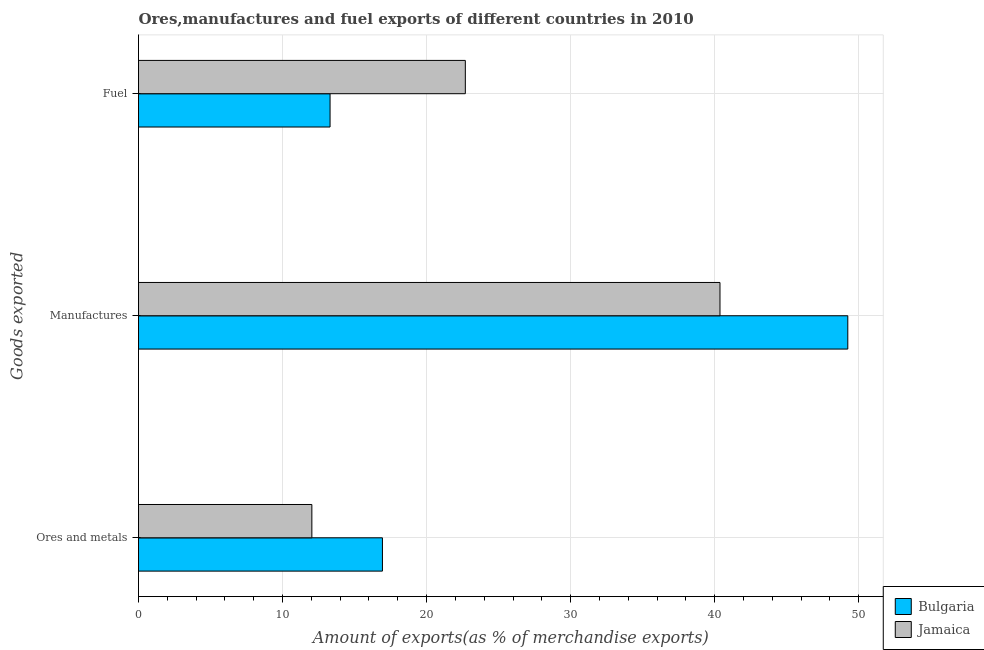How many different coloured bars are there?
Your answer should be very brief. 2. How many groups of bars are there?
Your answer should be compact. 3. Are the number of bars per tick equal to the number of legend labels?
Ensure brevity in your answer.  Yes. Are the number of bars on each tick of the Y-axis equal?
Your response must be concise. Yes. How many bars are there on the 3rd tick from the bottom?
Provide a short and direct response. 2. What is the label of the 3rd group of bars from the top?
Your response must be concise. Ores and metals. What is the percentage of manufactures exports in Bulgaria?
Provide a succinct answer. 49.24. Across all countries, what is the maximum percentage of ores and metals exports?
Offer a terse response. 16.93. Across all countries, what is the minimum percentage of fuel exports?
Give a very brief answer. 13.3. In which country was the percentage of fuel exports maximum?
Your answer should be very brief. Jamaica. In which country was the percentage of ores and metals exports minimum?
Provide a short and direct response. Jamaica. What is the total percentage of fuel exports in the graph?
Your response must be concise. 35.99. What is the difference between the percentage of fuel exports in Bulgaria and that in Jamaica?
Your answer should be compact. -9.39. What is the difference between the percentage of ores and metals exports in Jamaica and the percentage of manufactures exports in Bulgaria?
Keep it short and to the point. -37.21. What is the average percentage of manufactures exports per country?
Your answer should be very brief. 44.8. What is the difference between the percentage of fuel exports and percentage of ores and metals exports in Bulgaria?
Give a very brief answer. -3.64. In how many countries, is the percentage of fuel exports greater than 12 %?
Your answer should be compact. 2. What is the ratio of the percentage of ores and metals exports in Jamaica to that in Bulgaria?
Give a very brief answer. 0.71. Is the percentage of fuel exports in Bulgaria less than that in Jamaica?
Your answer should be compact. Yes. Is the difference between the percentage of manufactures exports in Jamaica and Bulgaria greater than the difference between the percentage of fuel exports in Jamaica and Bulgaria?
Provide a succinct answer. No. What is the difference between the highest and the second highest percentage of ores and metals exports?
Offer a very short reply. 4.9. What is the difference between the highest and the lowest percentage of ores and metals exports?
Your answer should be very brief. 4.9. In how many countries, is the percentage of fuel exports greater than the average percentage of fuel exports taken over all countries?
Your response must be concise. 1. Is the sum of the percentage of ores and metals exports in Jamaica and Bulgaria greater than the maximum percentage of fuel exports across all countries?
Your response must be concise. Yes. What does the 1st bar from the top in Ores and metals represents?
Your answer should be compact. Jamaica. What does the 2nd bar from the bottom in Fuel represents?
Provide a short and direct response. Jamaica. Is it the case that in every country, the sum of the percentage of ores and metals exports and percentage of manufactures exports is greater than the percentage of fuel exports?
Offer a very short reply. Yes. Are the values on the major ticks of X-axis written in scientific E-notation?
Your answer should be very brief. No. Does the graph contain any zero values?
Offer a terse response. No. Where does the legend appear in the graph?
Ensure brevity in your answer.  Bottom right. How are the legend labels stacked?
Give a very brief answer. Vertical. What is the title of the graph?
Your answer should be compact. Ores,manufactures and fuel exports of different countries in 2010. Does "Macao" appear as one of the legend labels in the graph?
Keep it short and to the point. No. What is the label or title of the X-axis?
Offer a very short reply. Amount of exports(as % of merchandise exports). What is the label or title of the Y-axis?
Keep it short and to the point. Goods exported. What is the Amount of exports(as % of merchandise exports) of Bulgaria in Ores and metals?
Offer a terse response. 16.93. What is the Amount of exports(as % of merchandise exports) in Jamaica in Ores and metals?
Your answer should be very brief. 12.03. What is the Amount of exports(as % of merchandise exports) of Bulgaria in Manufactures?
Offer a very short reply. 49.24. What is the Amount of exports(as % of merchandise exports) of Jamaica in Manufactures?
Provide a short and direct response. 40.37. What is the Amount of exports(as % of merchandise exports) of Bulgaria in Fuel?
Offer a very short reply. 13.3. What is the Amount of exports(as % of merchandise exports) of Jamaica in Fuel?
Provide a succinct answer. 22.69. Across all Goods exported, what is the maximum Amount of exports(as % of merchandise exports) of Bulgaria?
Make the answer very short. 49.24. Across all Goods exported, what is the maximum Amount of exports(as % of merchandise exports) of Jamaica?
Provide a short and direct response. 40.37. Across all Goods exported, what is the minimum Amount of exports(as % of merchandise exports) in Bulgaria?
Give a very brief answer. 13.3. Across all Goods exported, what is the minimum Amount of exports(as % of merchandise exports) in Jamaica?
Your response must be concise. 12.03. What is the total Amount of exports(as % of merchandise exports) of Bulgaria in the graph?
Your response must be concise. 79.47. What is the total Amount of exports(as % of merchandise exports) of Jamaica in the graph?
Your answer should be compact. 75.09. What is the difference between the Amount of exports(as % of merchandise exports) of Bulgaria in Ores and metals and that in Manufactures?
Provide a short and direct response. -32.31. What is the difference between the Amount of exports(as % of merchandise exports) of Jamaica in Ores and metals and that in Manufactures?
Provide a succinct answer. -28.33. What is the difference between the Amount of exports(as % of merchandise exports) of Bulgaria in Ores and metals and that in Fuel?
Offer a very short reply. 3.64. What is the difference between the Amount of exports(as % of merchandise exports) of Jamaica in Ores and metals and that in Fuel?
Your response must be concise. -10.65. What is the difference between the Amount of exports(as % of merchandise exports) in Bulgaria in Manufactures and that in Fuel?
Give a very brief answer. 35.94. What is the difference between the Amount of exports(as % of merchandise exports) in Jamaica in Manufactures and that in Fuel?
Ensure brevity in your answer.  17.68. What is the difference between the Amount of exports(as % of merchandise exports) in Bulgaria in Ores and metals and the Amount of exports(as % of merchandise exports) in Jamaica in Manufactures?
Offer a very short reply. -23.43. What is the difference between the Amount of exports(as % of merchandise exports) of Bulgaria in Ores and metals and the Amount of exports(as % of merchandise exports) of Jamaica in Fuel?
Your response must be concise. -5.75. What is the difference between the Amount of exports(as % of merchandise exports) of Bulgaria in Manufactures and the Amount of exports(as % of merchandise exports) of Jamaica in Fuel?
Ensure brevity in your answer.  26.55. What is the average Amount of exports(as % of merchandise exports) in Bulgaria per Goods exported?
Your response must be concise. 26.49. What is the average Amount of exports(as % of merchandise exports) in Jamaica per Goods exported?
Your answer should be compact. 25.03. What is the difference between the Amount of exports(as % of merchandise exports) in Bulgaria and Amount of exports(as % of merchandise exports) in Jamaica in Ores and metals?
Give a very brief answer. 4.9. What is the difference between the Amount of exports(as % of merchandise exports) in Bulgaria and Amount of exports(as % of merchandise exports) in Jamaica in Manufactures?
Give a very brief answer. 8.87. What is the difference between the Amount of exports(as % of merchandise exports) of Bulgaria and Amount of exports(as % of merchandise exports) of Jamaica in Fuel?
Make the answer very short. -9.39. What is the ratio of the Amount of exports(as % of merchandise exports) of Bulgaria in Ores and metals to that in Manufactures?
Keep it short and to the point. 0.34. What is the ratio of the Amount of exports(as % of merchandise exports) of Jamaica in Ores and metals to that in Manufactures?
Your answer should be compact. 0.3. What is the ratio of the Amount of exports(as % of merchandise exports) of Bulgaria in Ores and metals to that in Fuel?
Offer a terse response. 1.27. What is the ratio of the Amount of exports(as % of merchandise exports) in Jamaica in Ores and metals to that in Fuel?
Offer a very short reply. 0.53. What is the ratio of the Amount of exports(as % of merchandise exports) of Bulgaria in Manufactures to that in Fuel?
Offer a terse response. 3.7. What is the ratio of the Amount of exports(as % of merchandise exports) of Jamaica in Manufactures to that in Fuel?
Provide a short and direct response. 1.78. What is the difference between the highest and the second highest Amount of exports(as % of merchandise exports) in Bulgaria?
Offer a terse response. 32.31. What is the difference between the highest and the second highest Amount of exports(as % of merchandise exports) of Jamaica?
Give a very brief answer. 17.68. What is the difference between the highest and the lowest Amount of exports(as % of merchandise exports) of Bulgaria?
Keep it short and to the point. 35.94. What is the difference between the highest and the lowest Amount of exports(as % of merchandise exports) of Jamaica?
Your response must be concise. 28.33. 